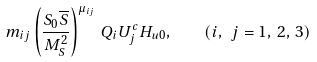Convert formula to latex. <formula><loc_0><loc_0><loc_500><loc_500>m _ { i j } \left ( \frac { S _ { 0 } { \overline { S } } } { M _ { S } ^ { 2 } } \right ) ^ { \mu _ { i j } } \, Q _ { i } U ^ { c } _ { j } H _ { u 0 } , \quad ( i , \ j = 1 , \, 2 , \, 3 )</formula> 